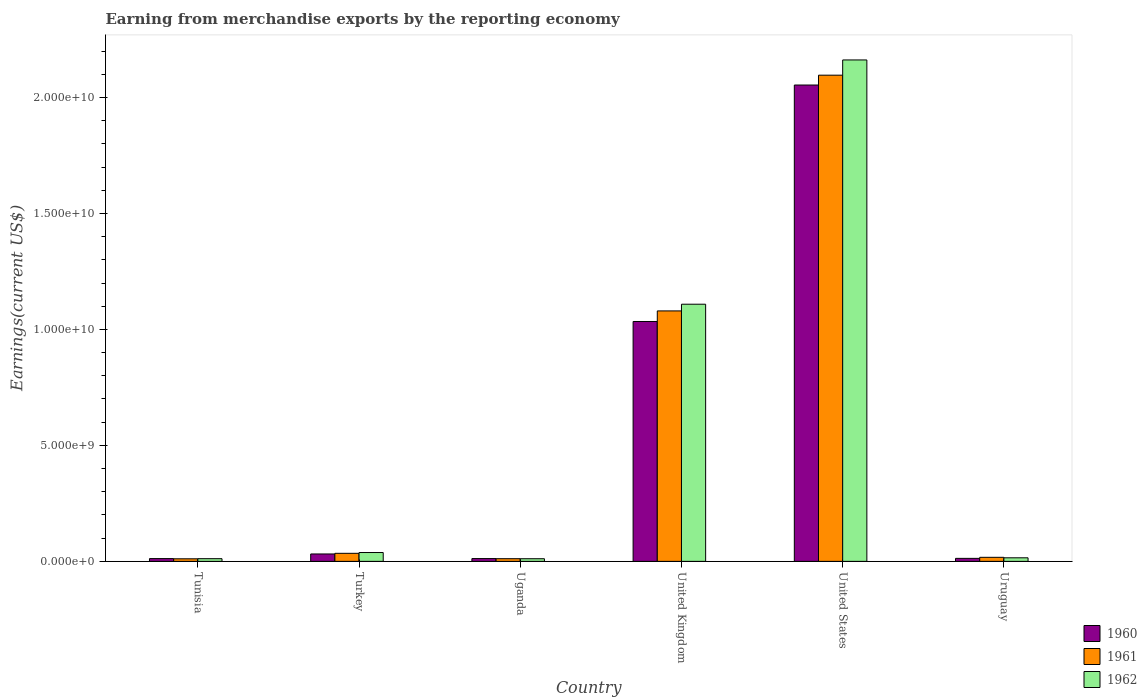How many different coloured bars are there?
Provide a short and direct response. 3. Are the number of bars per tick equal to the number of legend labels?
Make the answer very short. Yes. How many bars are there on the 3rd tick from the left?
Give a very brief answer. 3. What is the label of the 3rd group of bars from the left?
Ensure brevity in your answer.  Uganda. In how many cases, is the number of bars for a given country not equal to the number of legend labels?
Provide a short and direct response. 0. What is the amount earned from merchandise exports in 1960 in Tunisia?
Provide a succinct answer. 1.20e+08. Across all countries, what is the maximum amount earned from merchandise exports in 1962?
Provide a short and direct response. 2.16e+1. Across all countries, what is the minimum amount earned from merchandise exports in 1960?
Your answer should be very brief. 1.20e+08. In which country was the amount earned from merchandise exports in 1962 maximum?
Ensure brevity in your answer.  United States. In which country was the amount earned from merchandise exports in 1961 minimum?
Keep it short and to the point. Tunisia. What is the total amount earned from merchandise exports in 1960 in the graph?
Offer a very short reply. 3.16e+1. What is the difference between the amount earned from merchandise exports in 1961 in Uganda and that in United Kingdom?
Provide a short and direct response. -1.07e+1. What is the difference between the amount earned from merchandise exports in 1960 in Tunisia and the amount earned from merchandise exports in 1962 in Turkey?
Your answer should be compact. -2.61e+08. What is the average amount earned from merchandise exports in 1962 per country?
Keep it short and to the point. 5.58e+09. What is the difference between the amount earned from merchandise exports of/in 1962 and amount earned from merchandise exports of/in 1961 in United Kingdom?
Provide a succinct answer. 2.89e+08. What is the ratio of the amount earned from merchandise exports in 1962 in United Kingdom to that in Uruguay?
Give a very brief answer. 72.32. Is the difference between the amount earned from merchandise exports in 1962 in Turkey and Uruguay greater than the difference between the amount earned from merchandise exports in 1961 in Turkey and Uruguay?
Keep it short and to the point. Yes. What is the difference between the highest and the second highest amount earned from merchandise exports in 1960?
Your answer should be very brief. 1.02e+1. What is the difference between the highest and the lowest amount earned from merchandise exports in 1962?
Give a very brief answer. 2.15e+1. Is it the case that in every country, the sum of the amount earned from merchandise exports in 1961 and amount earned from merchandise exports in 1960 is greater than the amount earned from merchandise exports in 1962?
Make the answer very short. Yes. Are all the bars in the graph horizontal?
Your answer should be very brief. No. What is the difference between two consecutive major ticks on the Y-axis?
Your answer should be very brief. 5.00e+09. Does the graph contain any zero values?
Your answer should be very brief. No. How many legend labels are there?
Give a very brief answer. 3. What is the title of the graph?
Your answer should be compact. Earning from merchandise exports by the reporting economy. Does "1984" appear as one of the legend labels in the graph?
Make the answer very short. No. What is the label or title of the X-axis?
Provide a succinct answer. Country. What is the label or title of the Y-axis?
Your answer should be very brief. Earnings(current US$). What is the Earnings(current US$) of 1960 in Tunisia?
Ensure brevity in your answer.  1.20e+08. What is the Earnings(current US$) of 1961 in Tunisia?
Make the answer very short. 1.10e+08. What is the Earnings(current US$) of 1962 in Tunisia?
Make the answer very short. 1.16e+08. What is the Earnings(current US$) of 1960 in Turkey?
Your response must be concise. 3.19e+08. What is the Earnings(current US$) of 1961 in Turkey?
Your answer should be very brief. 3.47e+08. What is the Earnings(current US$) of 1962 in Turkey?
Ensure brevity in your answer.  3.81e+08. What is the Earnings(current US$) of 1960 in Uganda?
Provide a succinct answer. 1.20e+08. What is the Earnings(current US$) in 1961 in Uganda?
Provide a succinct answer. 1.15e+08. What is the Earnings(current US$) of 1962 in Uganda?
Your answer should be very brief. 1.14e+08. What is the Earnings(current US$) of 1960 in United Kingdom?
Give a very brief answer. 1.03e+1. What is the Earnings(current US$) in 1961 in United Kingdom?
Make the answer very short. 1.08e+1. What is the Earnings(current US$) of 1962 in United Kingdom?
Your response must be concise. 1.11e+1. What is the Earnings(current US$) in 1960 in United States?
Offer a very short reply. 2.05e+1. What is the Earnings(current US$) of 1961 in United States?
Keep it short and to the point. 2.10e+1. What is the Earnings(current US$) of 1962 in United States?
Your answer should be compact. 2.16e+1. What is the Earnings(current US$) of 1960 in Uruguay?
Offer a terse response. 1.30e+08. What is the Earnings(current US$) in 1961 in Uruguay?
Ensure brevity in your answer.  1.74e+08. What is the Earnings(current US$) in 1962 in Uruguay?
Offer a terse response. 1.53e+08. Across all countries, what is the maximum Earnings(current US$) in 1960?
Your response must be concise. 2.05e+1. Across all countries, what is the maximum Earnings(current US$) of 1961?
Your response must be concise. 2.10e+1. Across all countries, what is the maximum Earnings(current US$) in 1962?
Your answer should be compact. 2.16e+1. Across all countries, what is the minimum Earnings(current US$) of 1960?
Your answer should be very brief. 1.20e+08. Across all countries, what is the minimum Earnings(current US$) of 1961?
Your answer should be compact. 1.10e+08. Across all countries, what is the minimum Earnings(current US$) of 1962?
Make the answer very short. 1.14e+08. What is the total Earnings(current US$) of 1960 in the graph?
Keep it short and to the point. 3.16e+1. What is the total Earnings(current US$) in 1961 in the graph?
Provide a short and direct response. 3.25e+1. What is the total Earnings(current US$) of 1962 in the graph?
Your answer should be compact. 3.35e+1. What is the difference between the Earnings(current US$) in 1960 in Tunisia and that in Turkey?
Your response must be concise. -2.00e+08. What is the difference between the Earnings(current US$) in 1961 in Tunisia and that in Turkey?
Provide a succinct answer. -2.37e+08. What is the difference between the Earnings(current US$) of 1962 in Tunisia and that in Turkey?
Offer a very short reply. -2.65e+08. What is the difference between the Earnings(current US$) of 1960 in Tunisia and that in Uganda?
Offer a very short reply. -6.00e+05. What is the difference between the Earnings(current US$) of 1961 in Tunisia and that in Uganda?
Make the answer very short. -4.70e+06. What is the difference between the Earnings(current US$) of 1962 in Tunisia and that in Uganda?
Provide a succinct answer. 2.10e+06. What is the difference between the Earnings(current US$) of 1960 in Tunisia and that in United Kingdom?
Your response must be concise. -1.02e+1. What is the difference between the Earnings(current US$) of 1961 in Tunisia and that in United Kingdom?
Your answer should be compact. -1.07e+1. What is the difference between the Earnings(current US$) in 1962 in Tunisia and that in United Kingdom?
Your answer should be compact. -1.10e+1. What is the difference between the Earnings(current US$) in 1960 in Tunisia and that in United States?
Offer a terse response. -2.04e+1. What is the difference between the Earnings(current US$) of 1961 in Tunisia and that in United States?
Keep it short and to the point. -2.08e+1. What is the difference between the Earnings(current US$) of 1962 in Tunisia and that in United States?
Provide a succinct answer. -2.15e+1. What is the difference between the Earnings(current US$) of 1960 in Tunisia and that in Uruguay?
Your answer should be compact. -1.00e+07. What is the difference between the Earnings(current US$) in 1961 in Tunisia and that in Uruguay?
Your answer should be very brief. -6.40e+07. What is the difference between the Earnings(current US$) in 1962 in Tunisia and that in Uruguay?
Your answer should be compact. -3.76e+07. What is the difference between the Earnings(current US$) in 1960 in Turkey and that in Uganda?
Offer a very short reply. 1.99e+08. What is the difference between the Earnings(current US$) of 1961 in Turkey and that in Uganda?
Offer a very short reply. 2.32e+08. What is the difference between the Earnings(current US$) in 1962 in Turkey and that in Uganda?
Your answer should be very brief. 2.67e+08. What is the difference between the Earnings(current US$) in 1960 in Turkey and that in United Kingdom?
Provide a succinct answer. -1.00e+1. What is the difference between the Earnings(current US$) of 1961 in Turkey and that in United Kingdom?
Offer a very short reply. -1.05e+1. What is the difference between the Earnings(current US$) in 1962 in Turkey and that in United Kingdom?
Your response must be concise. -1.07e+1. What is the difference between the Earnings(current US$) of 1960 in Turkey and that in United States?
Offer a terse response. -2.02e+1. What is the difference between the Earnings(current US$) in 1961 in Turkey and that in United States?
Offer a terse response. -2.06e+1. What is the difference between the Earnings(current US$) of 1962 in Turkey and that in United States?
Make the answer very short. -2.12e+1. What is the difference between the Earnings(current US$) of 1960 in Turkey and that in Uruguay?
Give a very brief answer. 1.90e+08. What is the difference between the Earnings(current US$) of 1961 in Turkey and that in Uruguay?
Your response must be concise. 1.73e+08. What is the difference between the Earnings(current US$) of 1962 in Turkey and that in Uruguay?
Your response must be concise. 2.28e+08. What is the difference between the Earnings(current US$) in 1960 in Uganda and that in United Kingdom?
Give a very brief answer. -1.02e+1. What is the difference between the Earnings(current US$) of 1961 in Uganda and that in United Kingdom?
Your response must be concise. -1.07e+1. What is the difference between the Earnings(current US$) of 1962 in Uganda and that in United Kingdom?
Provide a succinct answer. -1.10e+1. What is the difference between the Earnings(current US$) in 1960 in Uganda and that in United States?
Provide a short and direct response. -2.04e+1. What is the difference between the Earnings(current US$) in 1961 in Uganda and that in United States?
Offer a terse response. -2.08e+1. What is the difference between the Earnings(current US$) in 1962 in Uganda and that in United States?
Provide a succinct answer. -2.15e+1. What is the difference between the Earnings(current US$) in 1960 in Uganda and that in Uruguay?
Ensure brevity in your answer.  -9.40e+06. What is the difference between the Earnings(current US$) of 1961 in Uganda and that in Uruguay?
Your response must be concise. -5.93e+07. What is the difference between the Earnings(current US$) of 1962 in Uganda and that in Uruguay?
Make the answer very short. -3.97e+07. What is the difference between the Earnings(current US$) of 1960 in United Kingdom and that in United States?
Keep it short and to the point. -1.02e+1. What is the difference between the Earnings(current US$) in 1961 in United Kingdom and that in United States?
Offer a very short reply. -1.02e+1. What is the difference between the Earnings(current US$) in 1962 in United Kingdom and that in United States?
Keep it short and to the point. -1.05e+1. What is the difference between the Earnings(current US$) of 1960 in United Kingdom and that in Uruguay?
Give a very brief answer. 1.02e+1. What is the difference between the Earnings(current US$) in 1961 in United Kingdom and that in Uruguay?
Ensure brevity in your answer.  1.06e+1. What is the difference between the Earnings(current US$) in 1962 in United Kingdom and that in Uruguay?
Make the answer very short. 1.09e+1. What is the difference between the Earnings(current US$) in 1960 in United States and that in Uruguay?
Ensure brevity in your answer.  2.04e+1. What is the difference between the Earnings(current US$) of 1961 in United States and that in Uruguay?
Your answer should be very brief. 2.08e+1. What is the difference between the Earnings(current US$) in 1962 in United States and that in Uruguay?
Ensure brevity in your answer.  2.15e+1. What is the difference between the Earnings(current US$) in 1960 in Tunisia and the Earnings(current US$) in 1961 in Turkey?
Offer a very short reply. -2.28e+08. What is the difference between the Earnings(current US$) of 1960 in Tunisia and the Earnings(current US$) of 1962 in Turkey?
Ensure brevity in your answer.  -2.61e+08. What is the difference between the Earnings(current US$) in 1961 in Tunisia and the Earnings(current US$) in 1962 in Turkey?
Offer a very short reply. -2.71e+08. What is the difference between the Earnings(current US$) in 1960 in Tunisia and the Earnings(current US$) in 1961 in Uganda?
Make the answer very short. 4.50e+06. What is the difference between the Earnings(current US$) in 1960 in Tunisia and the Earnings(current US$) in 1962 in Uganda?
Make the answer very short. 5.90e+06. What is the difference between the Earnings(current US$) of 1961 in Tunisia and the Earnings(current US$) of 1962 in Uganda?
Make the answer very short. -3.30e+06. What is the difference between the Earnings(current US$) in 1960 in Tunisia and the Earnings(current US$) in 1961 in United Kingdom?
Your answer should be very brief. -1.07e+1. What is the difference between the Earnings(current US$) in 1960 in Tunisia and the Earnings(current US$) in 1962 in United Kingdom?
Give a very brief answer. -1.10e+1. What is the difference between the Earnings(current US$) of 1961 in Tunisia and the Earnings(current US$) of 1962 in United Kingdom?
Your answer should be compact. -1.10e+1. What is the difference between the Earnings(current US$) in 1960 in Tunisia and the Earnings(current US$) in 1961 in United States?
Provide a short and direct response. -2.08e+1. What is the difference between the Earnings(current US$) of 1960 in Tunisia and the Earnings(current US$) of 1962 in United States?
Offer a very short reply. -2.15e+1. What is the difference between the Earnings(current US$) in 1961 in Tunisia and the Earnings(current US$) in 1962 in United States?
Give a very brief answer. -2.15e+1. What is the difference between the Earnings(current US$) of 1960 in Tunisia and the Earnings(current US$) of 1961 in Uruguay?
Give a very brief answer. -5.48e+07. What is the difference between the Earnings(current US$) of 1960 in Tunisia and the Earnings(current US$) of 1962 in Uruguay?
Your answer should be compact. -3.38e+07. What is the difference between the Earnings(current US$) of 1961 in Tunisia and the Earnings(current US$) of 1962 in Uruguay?
Make the answer very short. -4.30e+07. What is the difference between the Earnings(current US$) in 1960 in Turkey and the Earnings(current US$) in 1961 in Uganda?
Ensure brevity in your answer.  2.04e+08. What is the difference between the Earnings(current US$) of 1960 in Turkey and the Earnings(current US$) of 1962 in Uganda?
Keep it short and to the point. 2.05e+08. What is the difference between the Earnings(current US$) in 1961 in Turkey and the Earnings(current US$) in 1962 in Uganda?
Provide a succinct answer. 2.33e+08. What is the difference between the Earnings(current US$) of 1960 in Turkey and the Earnings(current US$) of 1961 in United Kingdom?
Provide a succinct answer. -1.05e+1. What is the difference between the Earnings(current US$) in 1960 in Turkey and the Earnings(current US$) in 1962 in United Kingdom?
Ensure brevity in your answer.  -1.08e+1. What is the difference between the Earnings(current US$) in 1961 in Turkey and the Earnings(current US$) in 1962 in United Kingdom?
Offer a terse response. -1.07e+1. What is the difference between the Earnings(current US$) of 1960 in Turkey and the Earnings(current US$) of 1961 in United States?
Make the answer very short. -2.06e+1. What is the difference between the Earnings(current US$) in 1960 in Turkey and the Earnings(current US$) in 1962 in United States?
Provide a short and direct response. -2.13e+1. What is the difference between the Earnings(current US$) in 1961 in Turkey and the Earnings(current US$) in 1962 in United States?
Make the answer very short. -2.13e+1. What is the difference between the Earnings(current US$) in 1960 in Turkey and the Earnings(current US$) in 1961 in Uruguay?
Your response must be concise. 1.45e+08. What is the difference between the Earnings(current US$) of 1960 in Turkey and the Earnings(current US$) of 1962 in Uruguay?
Ensure brevity in your answer.  1.66e+08. What is the difference between the Earnings(current US$) of 1961 in Turkey and the Earnings(current US$) of 1962 in Uruguay?
Ensure brevity in your answer.  1.94e+08. What is the difference between the Earnings(current US$) of 1960 in Uganda and the Earnings(current US$) of 1961 in United Kingdom?
Give a very brief answer. -1.07e+1. What is the difference between the Earnings(current US$) in 1960 in Uganda and the Earnings(current US$) in 1962 in United Kingdom?
Ensure brevity in your answer.  -1.10e+1. What is the difference between the Earnings(current US$) of 1961 in Uganda and the Earnings(current US$) of 1962 in United Kingdom?
Make the answer very short. -1.10e+1. What is the difference between the Earnings(current US$) of 1960 in Uganda and the Earnings(current US$) of 1961 in United States?
Provide a short and direct response. -2.08e+1. What is the difference between the Earnings(current US$) in 1960 in Uganda and the Earnings(current US$) in 1962 in United States?
Give a very brief answer. -2.15e+1. What is the difference between the Earnings(current US$) in 1961 in Uganda and the Earnings(current US$) in 1962 in United States?
Make the answer very short. -2.15e+1. What is the difference between the Earnings(current US$) of 1960 in Uganda and the Earnings(current US$) of 1961 in Uruguay?
Your response must be concise. -5.42e+07. What is the difference between the Earnings(current US$) in 1960 in Uganda and the Earnings(current US$) in 1962 in Uruguay?
Make the answer very short. -3.32e+07. What is the difference between the Earnings(current US$) in 1961 in Uganda and the Earnings(current US$) in 1962 in Uruguay?
Keep it short and to the point. -3.83e+07. What is the difference between the Earnings(current US$) in 1960 in United Kingdom and the Earnings(current US$) in 1961 in United States?
Provide a short and direct response. -1.06e+1. What is the difference between the Earnings(current US$) in 1960 in United Kingdom and the Earnings(current US$) in 1962 in United States?
Your answer should be compact. -1.13e+1. What is the difference between the Earnings(current US$) in 1961 in United Kingdom and the Earnings(current US$) in 1962 in United States?
Provide a succinct answer. -1.08e+1. What is the difference between the Earnings(current US$) in 1960 in United Kingdom and the Earnings(current US$) in 1961 in Uruguay?
Offer a very short reply. 1.02e+1. What is the difference between the Earnings(current US$) of 1960 in United Kingdom and the Earnings(current US$) of 1962 in Uruguay?
Offer a terse response. 1.02e+1. What is the difference between the Earnings(current US$) of 1961 in United Kingdom and the Earnings(current US$) of 1962 in Uruguay?
Your answer should be compact. 1.06e+1. What is the difference between the Earnings(current US$) in 1960 in United States and the Earnings(current US$) in 1961 in Uruguay?
Keep it short and to the point. 2.04e+1. What is the difference between the Earnings(current US$) in 1960 in United States and the Earnings(current US$) in 1962 in Uruguay?
Provide a short and direct response. 2.04e+1. What is the difference between the Earnings(current US$) of 1961 in United States and the Earnings(current US$) of 1962 in Uruguay?
Your answer should be compact. 2.08e+1. What is the average Earnings(current US$) in 1960 per country?
Offer a very short reply. 5.26e+09. What is the average Earnings(current US$) in 1961 per country?
Your answer should be compact. 5.42e+09. What is the average Earnings(current US$) in 1962 per country?
Provide a short and direct response. 5.58e+09. What is the difference between the Earnings(current US$) in 1960 and Earnings(current US$) in 1961 in Tunisia?
Give a very brief answer. 9.20e+06. What is the difference between the Earnings(current US$) in 1960 and Earnings(current US$) in 1962 in Tunisia?
Provide a short and direct response. 3.80e+06. What is the difference between the Earnings(current US$) in 1961 and Earnings(current US$) in 1962 in Tunisia?
Your response must be concise. -5.40e+06. What is the difference between the Earnings(current US$) in 1960 and Earnings(current US$) in 1961 in Turkey?
Provide a short and direct response. -2.80e+07. What is the difference between the Earnings(current US$) of 1960 and Earnings(current US$) of 1962 in Turkey?
Make the answer very short. -6.19e+07. What is the difference between the Earnings(current US$) of 1961 and Earnings(current US$) of 1962 in Turkey?
Your answer should be very brief. -3.39e+07. What is the difference between the Earnings(current US$) in 1960 and Earnings(current US$) in 1961 in Uganda?
Provide a succinct answer. 5.10e+06. What is the difference between the Earnings(current US$) of 1960 and Earnings(current US$) of 1962 in Uganda?
Give a very brief answer. 6.50e+06. What is the difference between the Earnings(current US$) of 1961 and Earnings(current US$) of 1962 in Uganda?
Give a very brief answer. 1.40e+06. What is the difference between the Earnings(current US$) in 1960 and Earnings(current US$) in 1961 in United Kingdom?
Offer a very short reply. -4.56e+08. What is the difference between the Earnings(current US$) in 1960 and Earnings(current US$) in 1962 in United Kingdom?
Provide a short and direct response. -7.45e+08. What is the difference between the Earnings(current US$) in 1961 and Earnings(current US$) in 1962 in United Kingdom?
Your response must be concise. -2.89e+08. What is the difference between the Earnings(current US$) of 1960 and Earnings(current US$) of 1961 in United States?
Keep it short and to the point. -4.24e+08. What is the difference between the Earnings(current US$) of 1960 and Earnings(current US$) of 1962 in United States?
Your answer should be very brief. -1.08e+09. What is the difference between the Earnings(current US$) in 1961 and Earnings(current US$) in 1962 in United States?
Offer a terse response. -6.57e+08. What is the difference between the Earnings(current US$) of 1960 and Earnings(current US$) of 1961 in Uruguay?
Offer a very short reply. -4.48e+07. What is the difference between the Earnings(current US$) in 1960 and Earnings(current US$) in 1962 in Uruguay?
Make the answer very short. -2.38e+07. What is the difference between the Earnings(current US$) in 1961 and Earnings(current US$) in 1962 in Uruguay?
Make the answer very short. 2.10e+07. What is the ratio of the Earnings(current US$) of 1960 in Tunisia to that in Turkey?
Offer a very short reply. 0.37. What is the ratio of the Earnings(current US$) of 1961 in Tunisia to that in Turkey?
Your answer should be very brief. 0.32. What is the ratio of the Earnings(current US$) of 1962 in Tunisia to that in Turkey?
Make the answer very short. 0.3. What is the ratio of the Earnings(current US$) in 1961 in Tunisia to that in Uganda?
Provide a short and direct response. 0.96. What is the ratio of the Earnings(current US$) in 1962 in Tunisia to that in Uganda?
Your answer should be very brief. 1.02. What is the ratio of the Earnings(current US$) in 1960 in Tunisia to that in United Kingdom?
Make the answer very short. 0.01. What is the ratio of the Earnings(current US$) of 1961 in Tunisia to that in United Kingdom?
Provide a succinct answer. 0.01. What is the ratio of the Earnings(current US$) in 1962 in Tunisia to that in United Kingdom?
Keep it short and to the point. 0.01. What is the ratio of the Earnings(current US$) of 1960 in Tunisia to that in United States?
Ensure brevity in your answer.  0.01. What is the ratio of the Earnings(current US$) in 1961 in Tunisia to that in United States?
Your answer should be very brief. 0.01. What is the ratio of the Earnings(current US$) of 1962 in Tunisia to that in United States?
Give a very brief answer. 0.01. What is the ratio of the Earnings(current US$) in 1960 in Tunisia to that in Uruguay?
Provide a short and direct response. 0.92. What is the ratio of the Earnings(current US$) of 1961 in Tunisia to that in Uruguay?
Offer a terse response. 0.63. What is the ratio of the Earnings(current US$) of 1962 in Tunisia to that in Uruguay?
Make the answer very short. 0.75. What is the ratio of the Earnings(current US$) of 1960 in Turkey to that in Uganda?
Your response must be concise. 2.66. What is the ratio of the Earnings(current US$) of 1961 in Turkey to that in Uganda?
Provide a succinct answer. 3.02. What is the ratio of the Earnings(current US$) in 1962 in Turkey to that in Uganda?
Give a very brief answer. 3.35. What is the ratio of the Earnings(current US$) in 1960 in Turkey to that in United Kingdom?
Offer a very short reply. 0.03. What is the ratio of the Earnings(current US$) of 1961 in Turkey to that in United Kingdom?
Offer a very short reply. 0.03. What is the ratio of the Earnings(current US$) in 1962 in Turkey to that in United Kingdom?
Your answer should be very brief. 0.03. What is the ratio of the Earnings(current US$) of 1960 in Turkey to that in United States?
Offer a terse response. 0.02. What is the ratio of the Earnings(current US$) of 1961 in Turkey to that in United States?
Provide a succinct answer. 0.02. What is the ratio of the Earnings(current US$) in 1962 in Turkey to that in United States?
Keep it short and to the point. 0.02. What is the ratio of the Earnings(current US$) in 1960 in Turkey to that in Uruguay?
Provide a succinct answer. 2.46. What is the ratio of the Earnings(current US$) in 1961 in Turkey to that in Uruguay?
Your response must be concise. 1.99. What is the ratio of the Earnings(current US$) in 1962 in Turkey to that in Uruguay?
Offer a very short reply. 2.48. What is the ratio of the Earnings(current US$) of 1960 in Uganda to that in United Kingdom?
Ensure brevity in your answer.  0.01. What is the ratio of the Earnings(current US$) in 1961 in Uganda to that in United Kingdom?
Your answer should be very brief. 0.01. What is the ratio of the Earnings(current US$) in 1962 in Uganda to that in United Kingdom?
Make the answer very short. 0.01. What is the ratio of the Earnings(current US$) in 1960 in Uganda to that in United States?
Give a very brief answer. 0.01. What is the ratio of the Earnings(current US$) in 1961 in Uganda to that in United States?
Offer a terse response. 0.01. What is the ratio of the Earnings(current US$) in 1962 in Uganda to that in United States?
Your answer should be very brief. 0.01. What is the ratio of the Earnings(current US$) of 1960 in Uganda to that in Uruguay?
Provide a short and direct response. 0.93. What is the ratio of the Earnings(current US$) of 1961 in Uganda to that in Uruguay?
Your answer should be compact. 0.66. What is the ratio of the Earnings(current US$) of 1962 in Uganda to that in Uruguay?
Provide a short and direct response. 0.74. What is the ratio of the Earnings(current US$) in 1960 in United Kingdom to that in United States?
Offer a terse response. 0.5. What is the ratio of the Earnings(current US$) in 1961 in United Kingdom to that in United States?
Your response must be concise. 0.52. What is the ratio of the Earnings(current US$) of 1962 in United Kingdom to that in United States?
Offer a very short reply. 0.51. What is the ratio of the Earnings(current US$) of 1960 in United Kingdom to that in Uruguay?
Ensure brevity in your answer.  79.85. What is the ratio of the Earnings(current US$) in 1961 in United Kingdom to that in Uruguay?
Your answer should be very brief. 61.95. What is the ratio of the Earnings(current US$) of 1962 in United Kingdom to that in Uruguay?
Your response must be concise. 72.32. What is the ratio of the Earnings(current US$) of 1960 in United States to that in Uruguay?
Your answer should be compact. 158.58. What is the ratio of the Earnings(current US$) of 1961 in United States to that in Uruguay?
Provide a succinct answer. 120.25. What is the ratio of the Earnings(current US$) in 1962 in United States to that in Uruguay?
Your answer should be very brief. 141.01. What is the difference between the highest and the second highest Earnings(current US$) in 1960?
Offer a terse response. 1.02e+1. What is the difference between the highest and the second highest Earnings(current US$) in 1961?
Ensure brevity in your answer.  1.02e+1. What is the difference between the highest and the second highest Earnings(current US$) of 1962?
Give a very brief answer. 1.05e+1. What is the difference between the highest and the lowest Earnings(current US$) of 1960?
Your answer should be compact. 2.04e+1. What is the difference between the highest and the lowest Earnings(current US$) in 1961?
Your answer should be compact. 2.08e+1. What is the difference between the highest and the lowest Earnings(current US$) of 1962?
Give a very brief answer. 2.15e+1. 